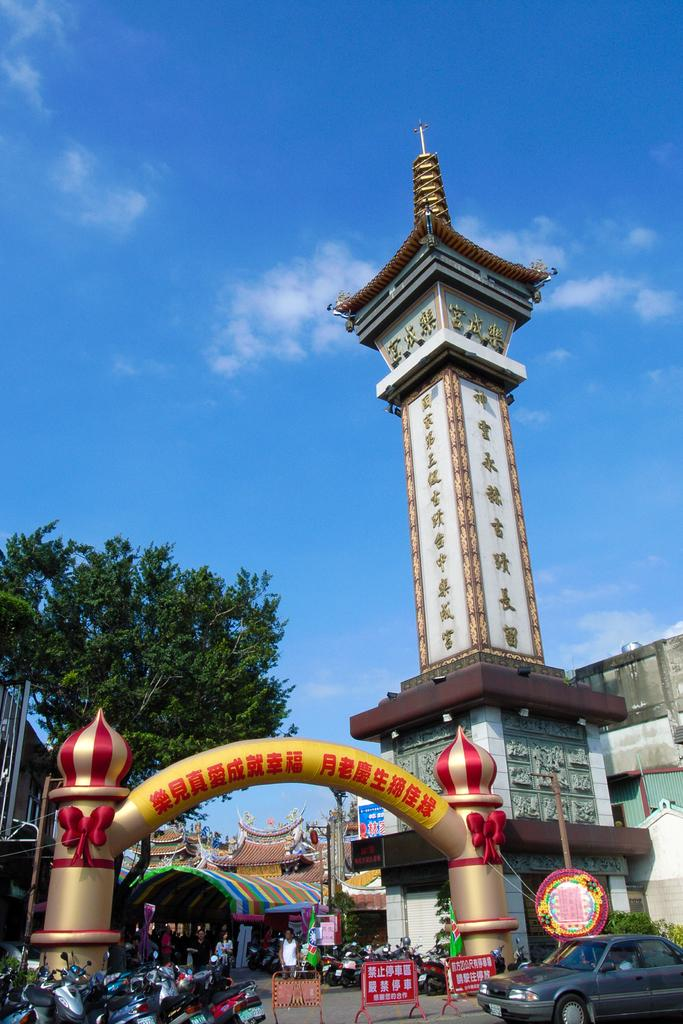What structure can be seen in the image? There is an arch in the image. What is written on the arch? There is writing on the arch. What can be seen in the background of the image? There are trees in the backdrop of the image. What type of man-made structures are present in the image? There are buildings in the image. What mode of transportation can be seen in the image? Vehicles are parked in the image. What is the condition of the sky in the image? The sky is clear in the image. How many grapes are hanging from the arch in the image? There are no grapes present in the image, as it features an arch with writing and a clear sky. 